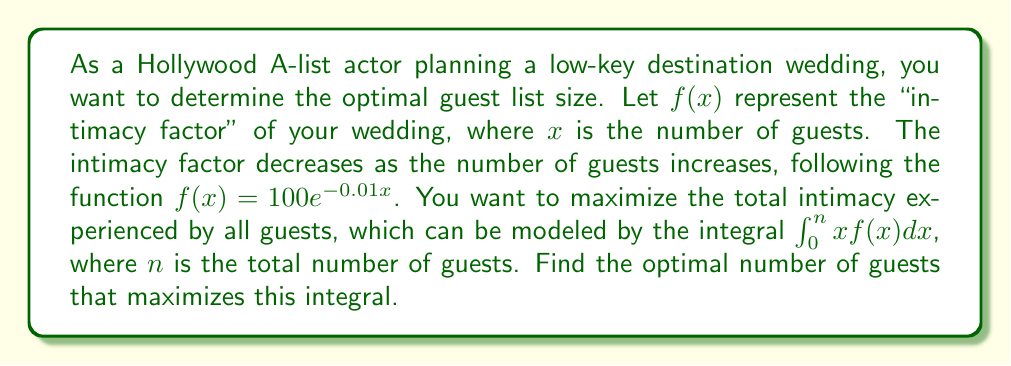Can you answer this question? To solve this problem, we need to follow these steps:

1. Set up the integral to maximize:
   $$I(n) = \int_0^n xf(x)dx = \int_0^n x(100e^{-0.01x})dx$$

2. Evaluate the integral:
   $$I(n) = 100\int_0^n xe^{-0.01x}dx$$
   Let $u = -0.01x$, then $du = -0.01dx$ and $x = -100u$
   $$I(n) = -10000\int_0^{-0.01n} ue^u du$$
   Integrate by parts: $\int udv = uv - \int vdu$
   $$I(n) = -10000\left[ue^u\big|_0^{-0.01n} - \int_0^{-0.01n} e^u du\right]$$
   $$I(n) = -10000\left[(-0.01n)e^{-0.01n} - (0) - (e^{-0.01n} - 1)\right]$$
   $$I(n) = 10000\left[(100 + n)e^{-0.01n} - 100\right]$$

3. To find the maximum, differentiate $I(n)$ with respect to $n$ and set it to zero:
   $$\frac{dI}{dn} = 10000\left[(1 - 0.01(100 + n))e^{-0.01n}\right] = 0$$

4. Solve the equation:
   $1 - 0.01(100 + n) = 0$
   $1 - 1 - 0.01n = 0$
   $-0.01n = 0$
   $n = 0$

5. Check the second derivative to confirm it's a maximum:
   $$\frac{d^2I}{dn^2} = -100(2 - 0.01n)e^{-0.01n}$$
   At $n = 0$, this is negative, confirming a maximum.

6. Since $n = 0$ is not a practical solution, we need to find the next best integer value. We can evaluate $I(n)$ for small integer values of $n$ to find the practical optimum.

   $I(1) = 9900.99$
   $I(2) = 19603.94$
   $I(3) = 29110.88$
   $I(4) = 38423.95$
   $I(5) = 47545.31$

The values continue to increase but at a decreasing rate. The optimal number of guests would depend on the minimum number of close friends and family you want to invite.
Answer: The mathematical optimum is 0 guests, but a practical optimum would be the minimum number of close friends and family desired, as the intimacy factor decreases with each additional guest. 